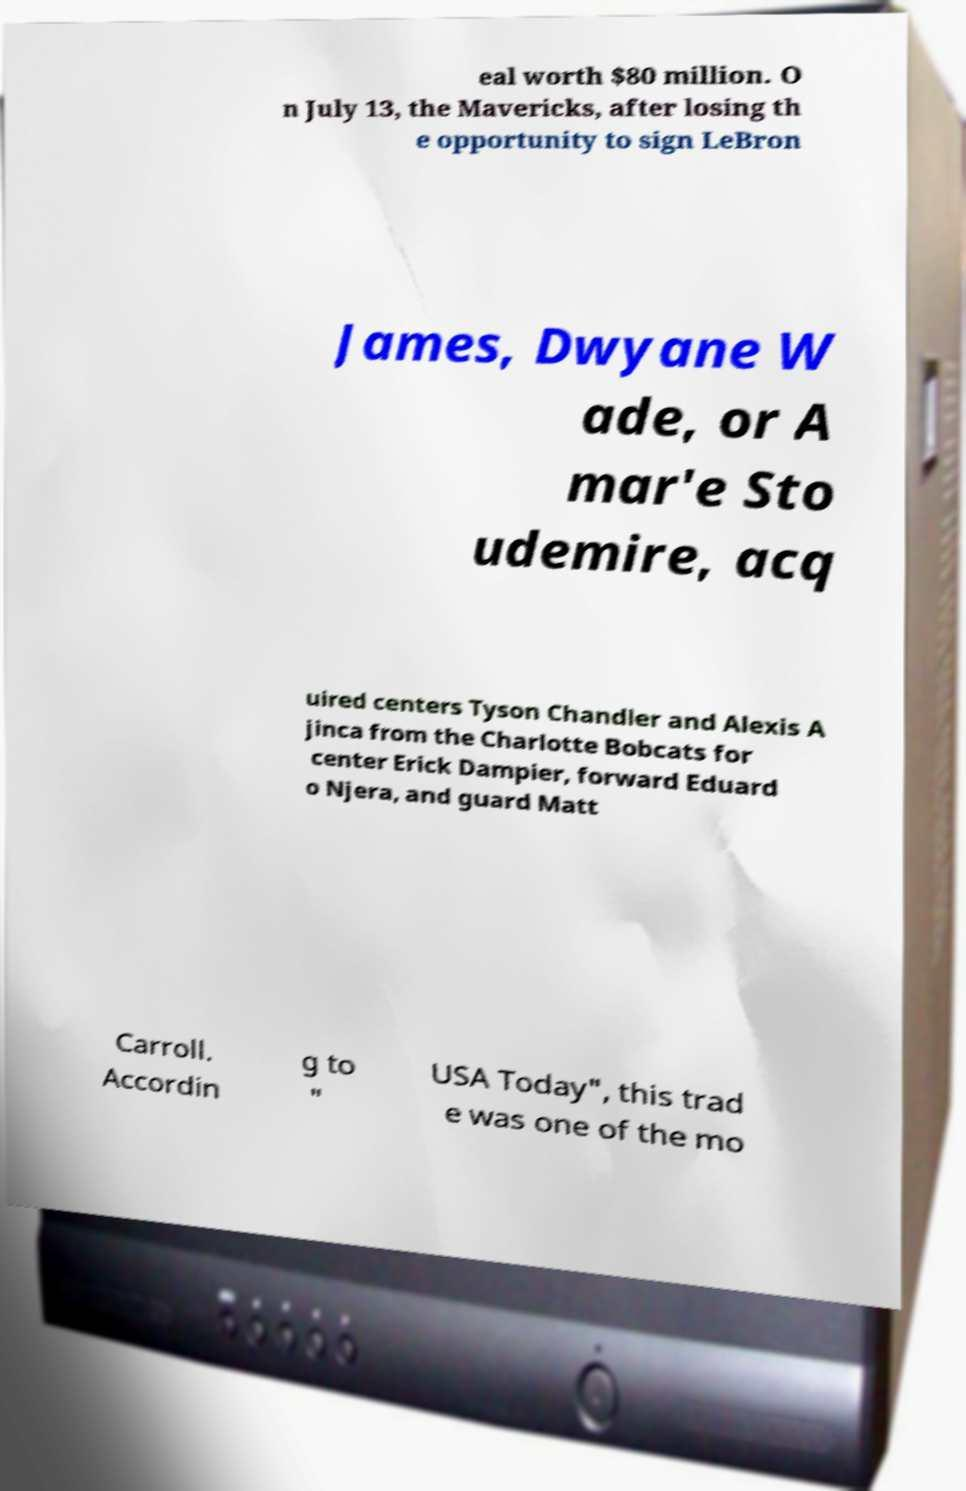Could you assist in decoding the text presented in this image and type it out clearly? eal worth $80 million. O n July 13, the Mavericks, after losing th e opportunity to sign LeBron James, Dwyane W ade, or A mar'e Sto udemire, acq uired centers Tyson Chandler and Alexis A jinca from the Charlotte Bobcats for center Erick Dampier, forward Eduard o Njera, and guard Matt Carroll. Accordin g to " USA Today", this trad e was one of the mo 